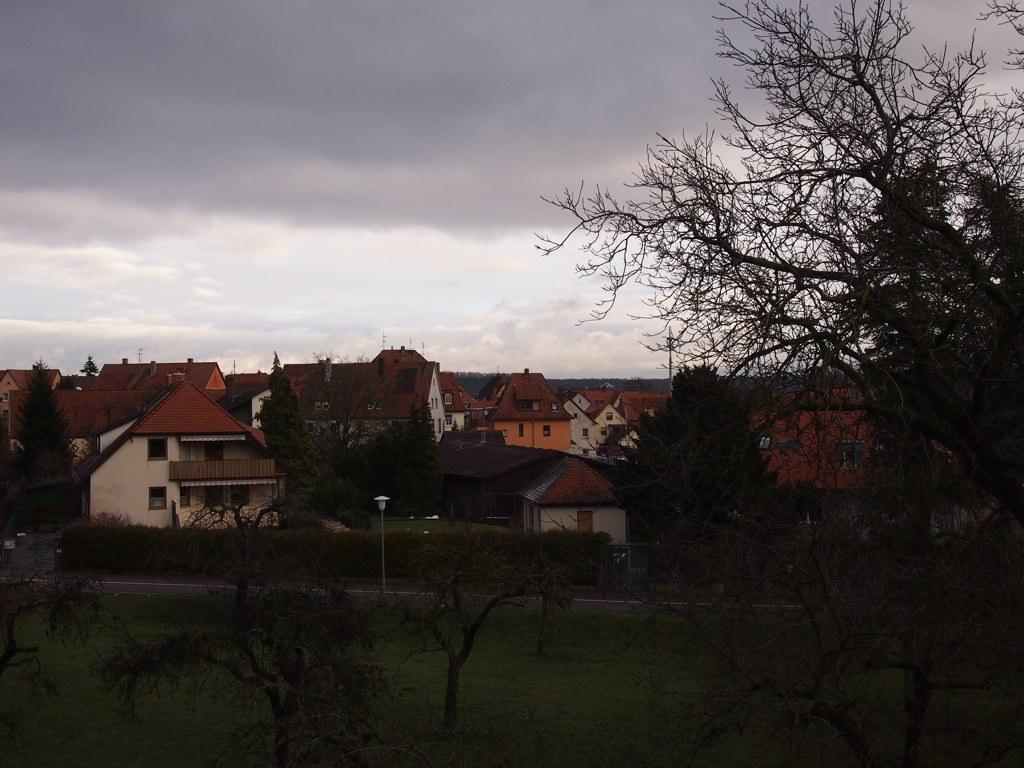How would you summarize this image in a sentence or two? Here there are houses with the windows, here there are trees and this is a sky. 